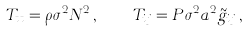Convert formula to latex. <formula><loc_0><loc_0><loc_500><loc_500>T _ { t t } = \rho \sigma ^ { 2 } N ^ { 2 } \, , \quad T _ { i j } = P \sigma ^ { 2 } a ^ { 2 } \tilde { g } _ { i j } \, ,</formula> 